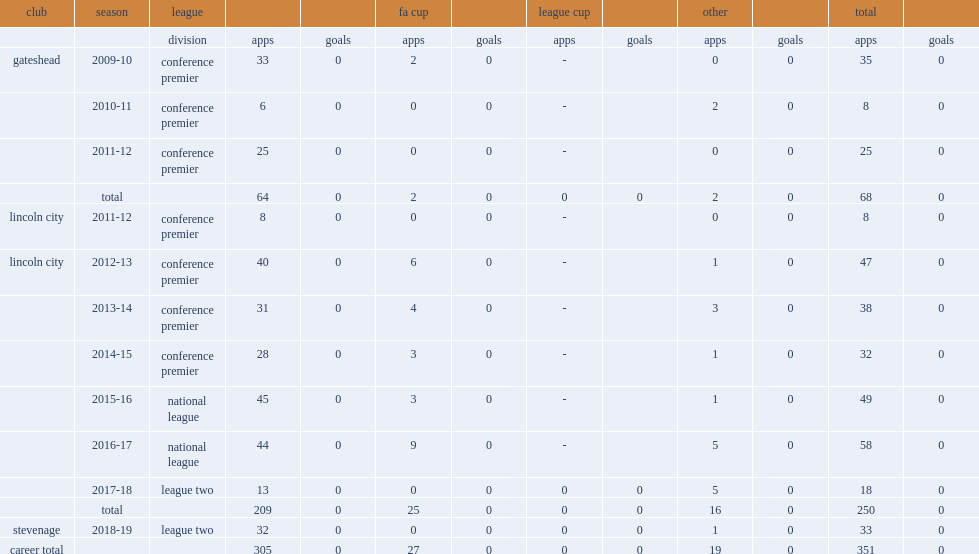Which club did paul farman play for in 2009-10? Gateshead. 